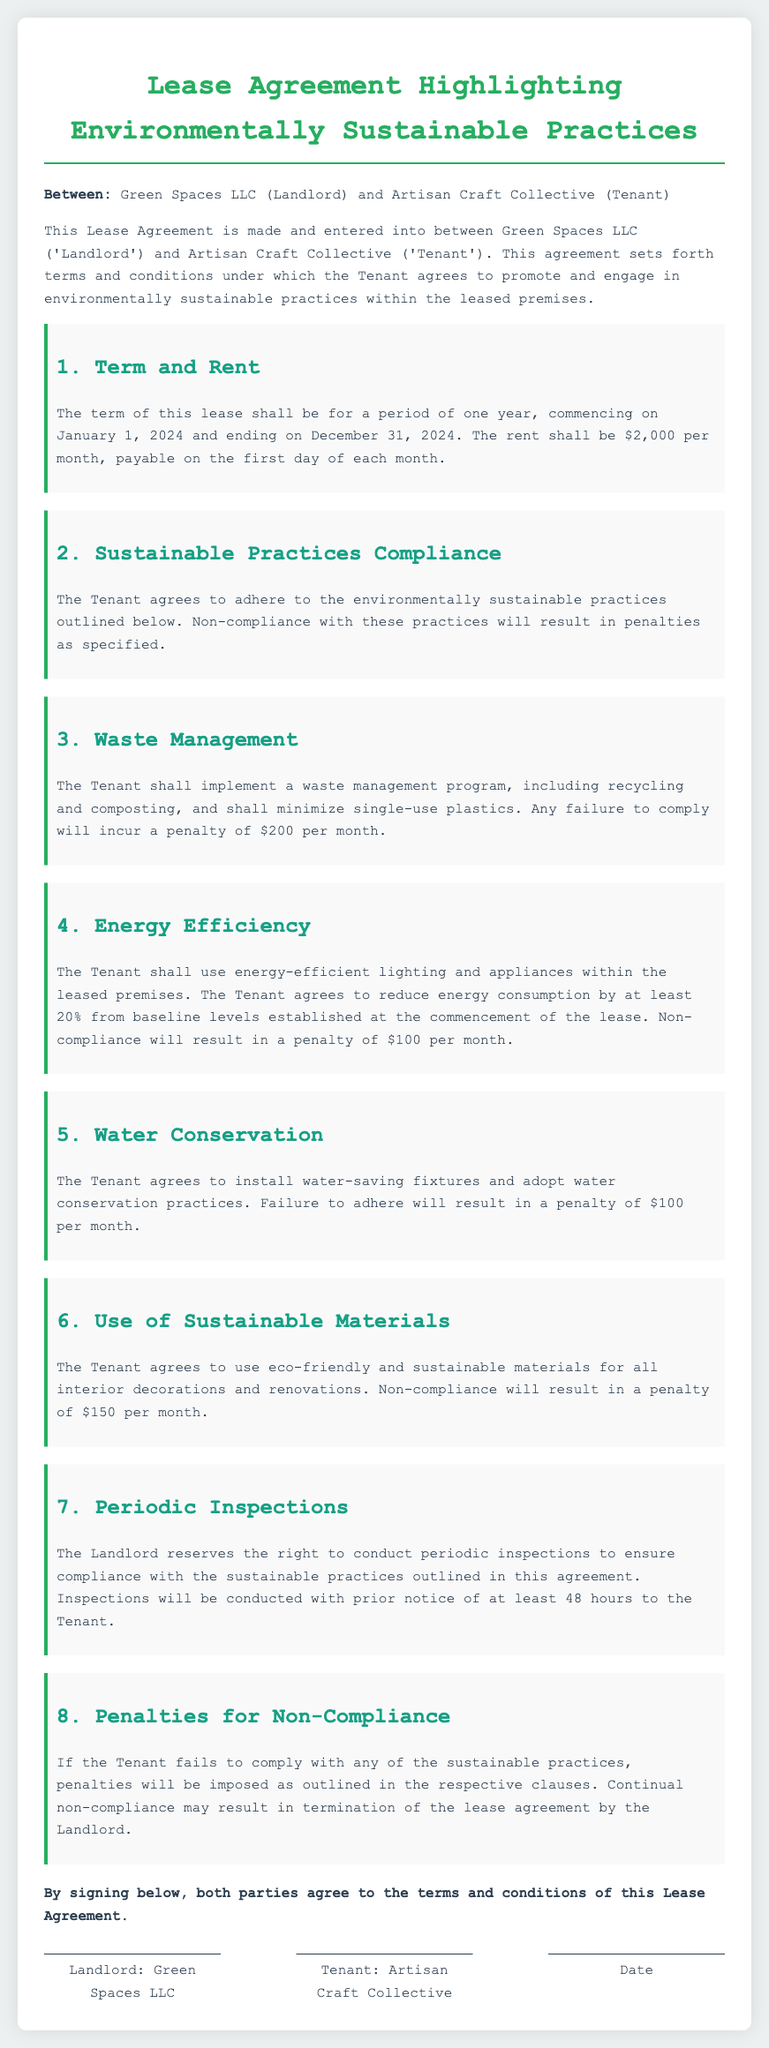What is the name of the landlord? The landlord is specified in the document as Green Spaces LLC.
Answer: Green Spaces LLC What is the monthly rent amount? The document states the rent shall be $2,000 per month.
Answer: $2,000 When does the lease commence? The lease agreement specifies that it commences on January 1, 2024.
Answer: January 1, 2024 What is the penalty for non-compliance with waste management? The document details that the penalty for non-compliance with waste management is $200 per month.
Answer: $200 What percentage reduction in energy consumption is required? The lease requires the Tenant to reduce energy consumption by at least 20% from baseline levels.
Answer: 20% How often can the landlord conduct inspections? The landlord reserves the right to conduct inspections periodically with prior notice of at least 48 hours.
Answer: Periodically What happens after continual non-compliance? The lease states that continual non-compliance may result in termination of the lease agreement by the landlord.
Answer: Termination What is required for water conservation? The Tenant agrees to install water-saving fixtures and adopt water conservation practices.
Answer: Water-saving fixtures What is the penalty for using non-sustainable materials? The document specifies that using non-sustainable materials incurs a penalty of $150 per month.
Answer: $150 